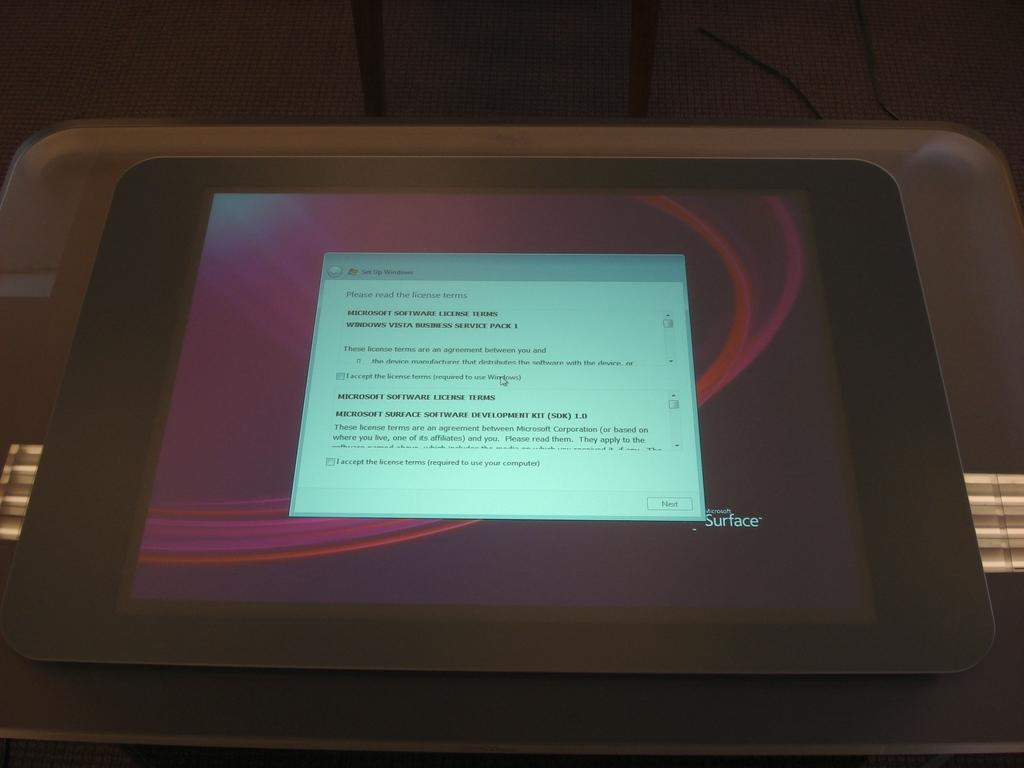What electronic device is visible in the image? There is a tablet in the image. Where is the tablet located? The tablet is placed on a table. How many clams are on the tablet in the image? There are no clams present in the image; it only features a tablet placed on a table. 